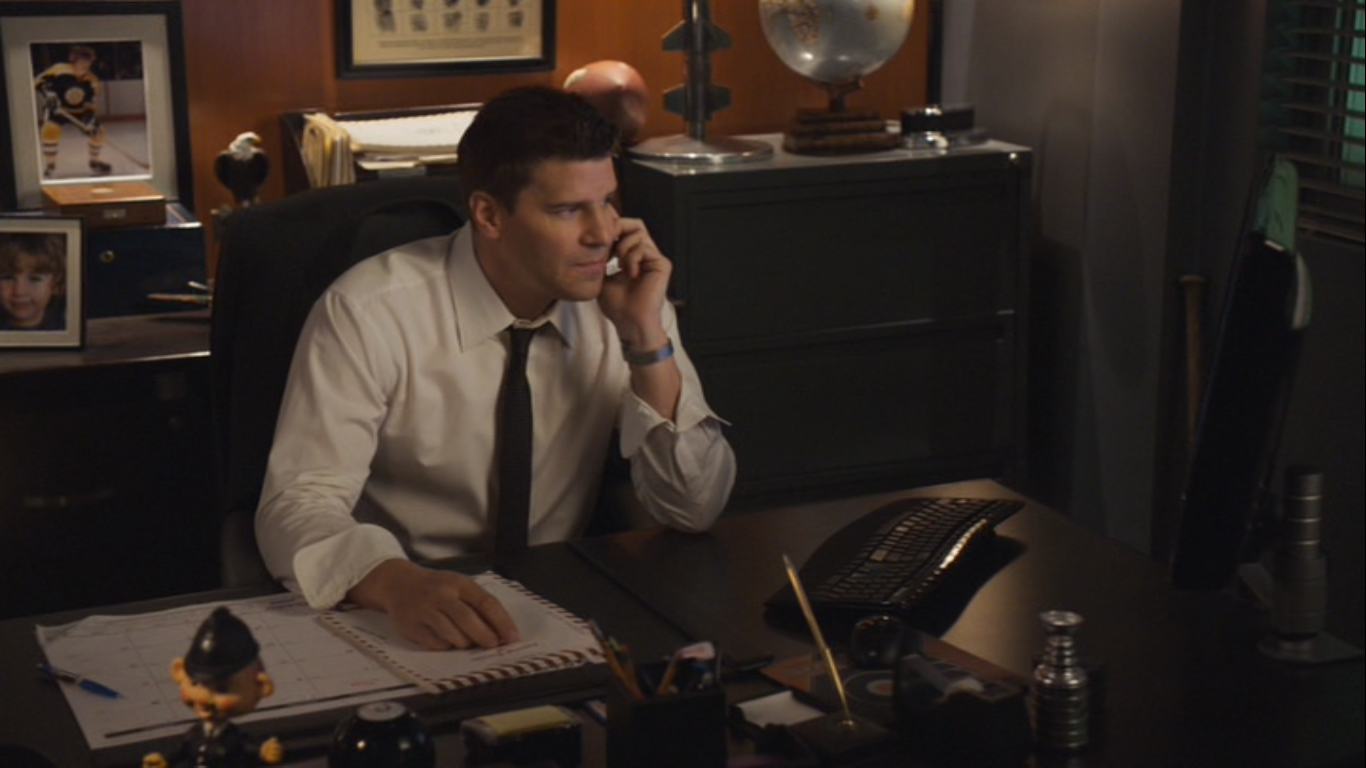If this image were part of a dramatic scene, what event might be unfolding? In this dramatic scene, the character might be receiving a crucial phone call that holds key information about an ongoing investigation. As a detective or special agent, he could be learning about a new lead or a breakthrough in a case he has been working on. The intensity in his eyes and his poised posture suggest that the information is vital. Perhaps he is discussing the logistics of an operation, coordinating with a team, or even strategizing the next steps to apprehend a suspect. The setting, with its professional and serious tone, implies that the stakes are high and the situation requires his full attention and immediate action. What kind of investigation might he be involved in? Use your imagination. Imagine he's deep in the midst of an international investigation involving a high-stakes art theft syndicate. The phone call might be from an undercover agent who has infiltrated the organization, providing insider information about the next heist's location and timing. Alternatively, he could be tracking an elusive cybercriminal whose hacking expertise threatens national security. Each clue he gathers from this call leads him a step closer to preventing a cyber-attack on crucial infrastructure. The photograph of a child on his desk could symbolize his personal motivation to solve the case, perhaps a reminder of someone he's vowed to protect from such threats. Every object in the room, from the globe to the notepad, represents tools and symbols central to unraveling this complex, globe-spanning mystery. 